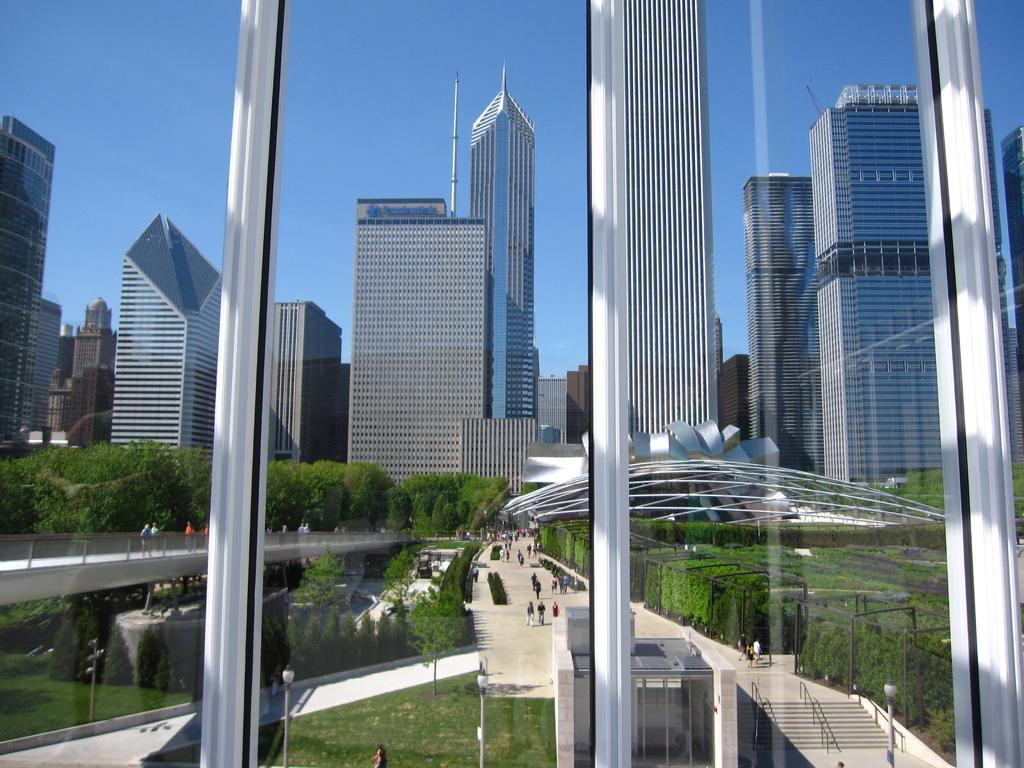How would you summarize this image in a sentence or two? In this picture I can see window glasses in front and through the glasses I see the trees and plants and I see the path on which there are number of people and I see few light poles. In the middle of this picture I see number of buildings and in the background I see the sky. 